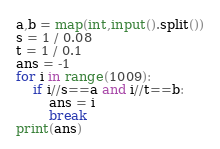Convert code to text. <code><loc_0><loc_0><loc_500><loc_500><_Python_>a,b = map(int,input().split())
s = 1 / 0.08
t = 1 / 0.1
ans = -1
for i in range(1009):
    if i//s==a and i//t==b:
        ans = i
        break
print(ans)</code> 